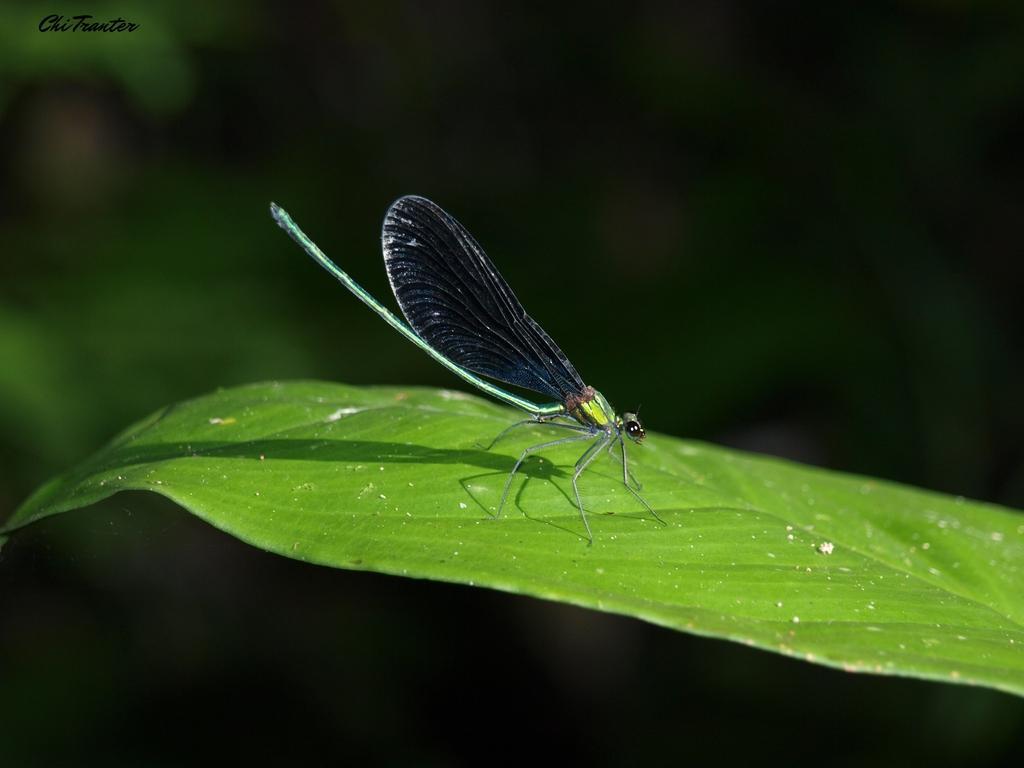Can you describe this image briefly? In this picture there is a dragonfly on the green leaf. At the back image is blurry. At the top left there is a text. 